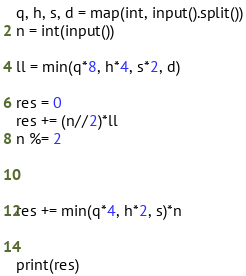Convert code to text. <code><loc_0><loc_0><loc_500><loc_500><_Python_>q, h, s, d = map(int, input().split())
n = int(input())

ll = min(q*8, h*4, s*2, d)

res = 0
res += (n//2)*ll
n %= 2



res += min(q*4, h*2, s)*n


print(res)</code> 